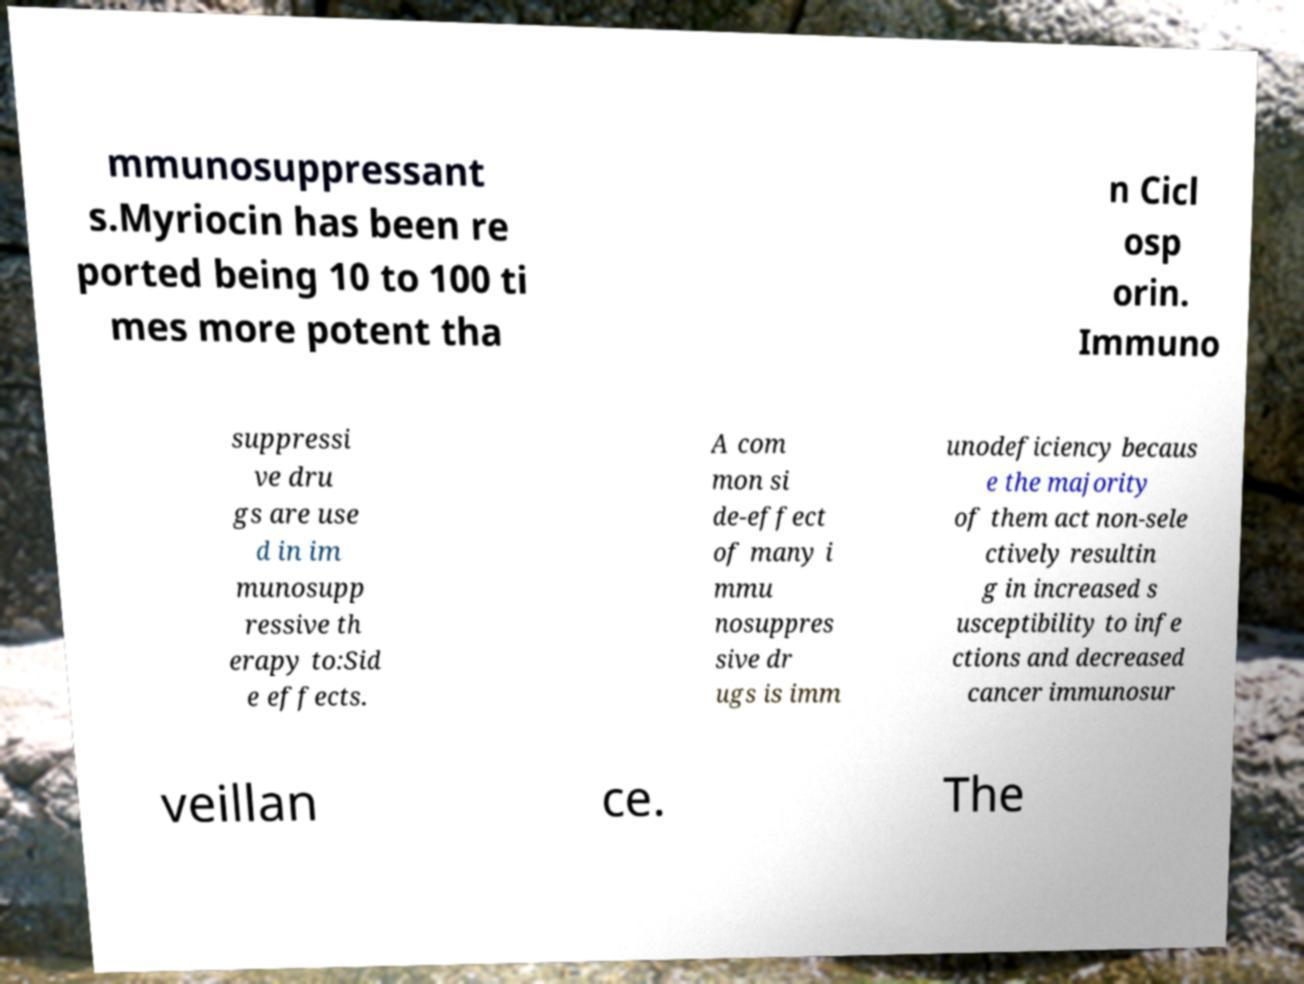There's text embedded in this image that I need extracted. Can you transcribe it verbatim? mmunosuppressant s.Myriocin has been re ported being 10 to 100 ti mes more potent tha n Cicl osp orin. Immuno suppressi ve dru gs are use d in im munosupp ressive th erapy to:Sid e effects. A com mon si de-effect of many i mmu nosuppres sive dr ugs is imm unodeficiency becaus e the majority of them act non-sele ctively resultin g in increased s usceptibility to infe ctions and decreased cancer immunosur veillan ce. The 